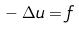<formula> <loc_0><loc_0><loc_500><loc_500>{ } - \Delta u = f</formula> 